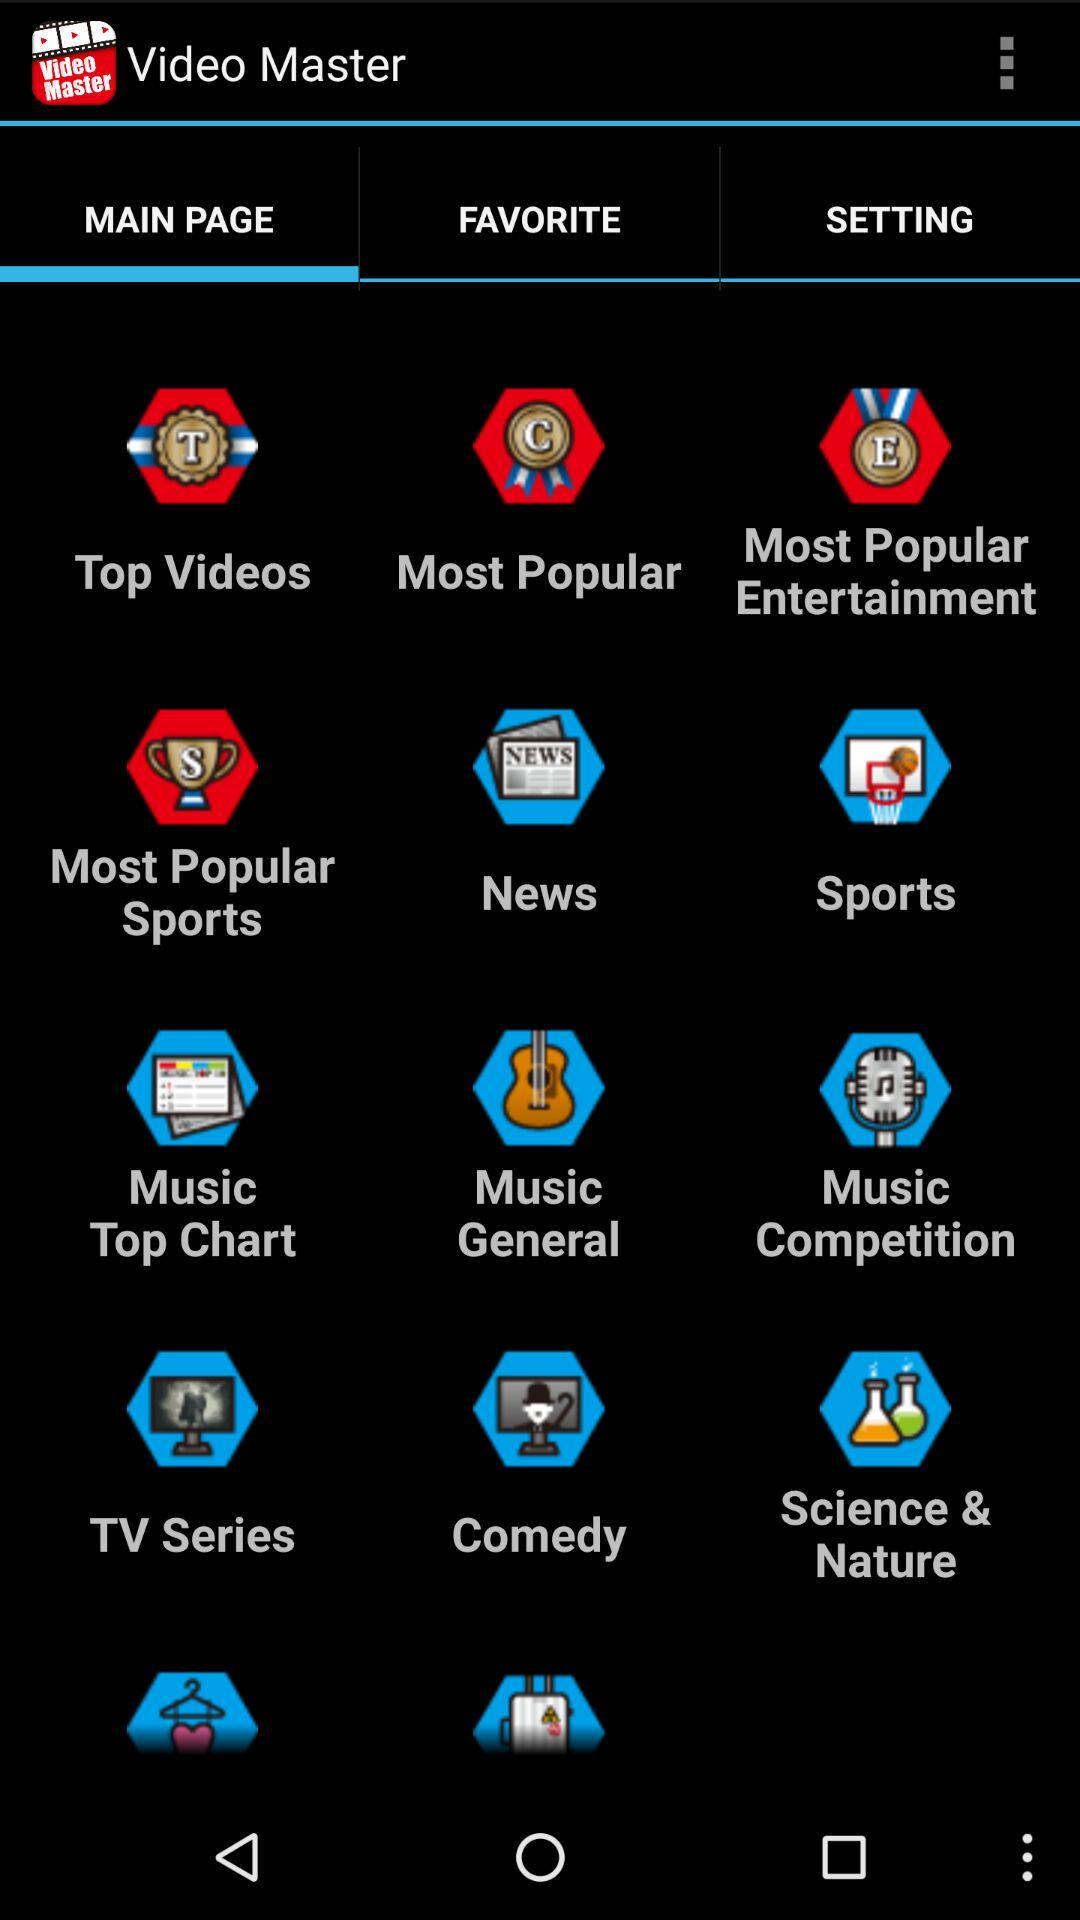Which topics are listed in "FAVORITE"?
When the provided information is insufficient, respond with <no answer>. <no answer> 